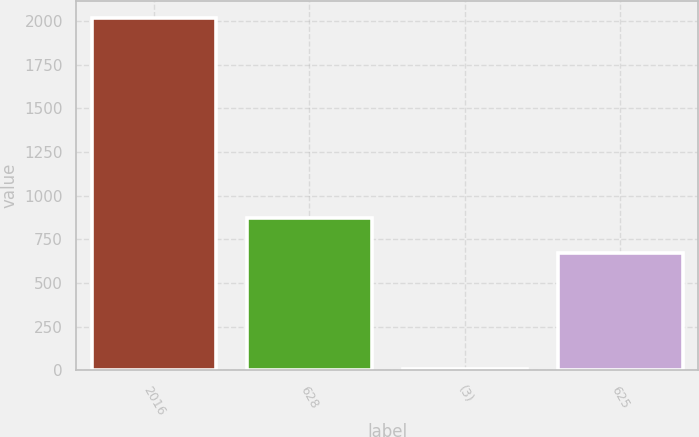Convert chart to OTSL. <chart><loc_0><loc_0><loc_500><loc_500><bar_chart><fcel>2016<fcel>628<fcel>(3)<fcel>625<nl><fcel>2015<fcel>871.9<fcel>6<fcel>671<nl></chart> 